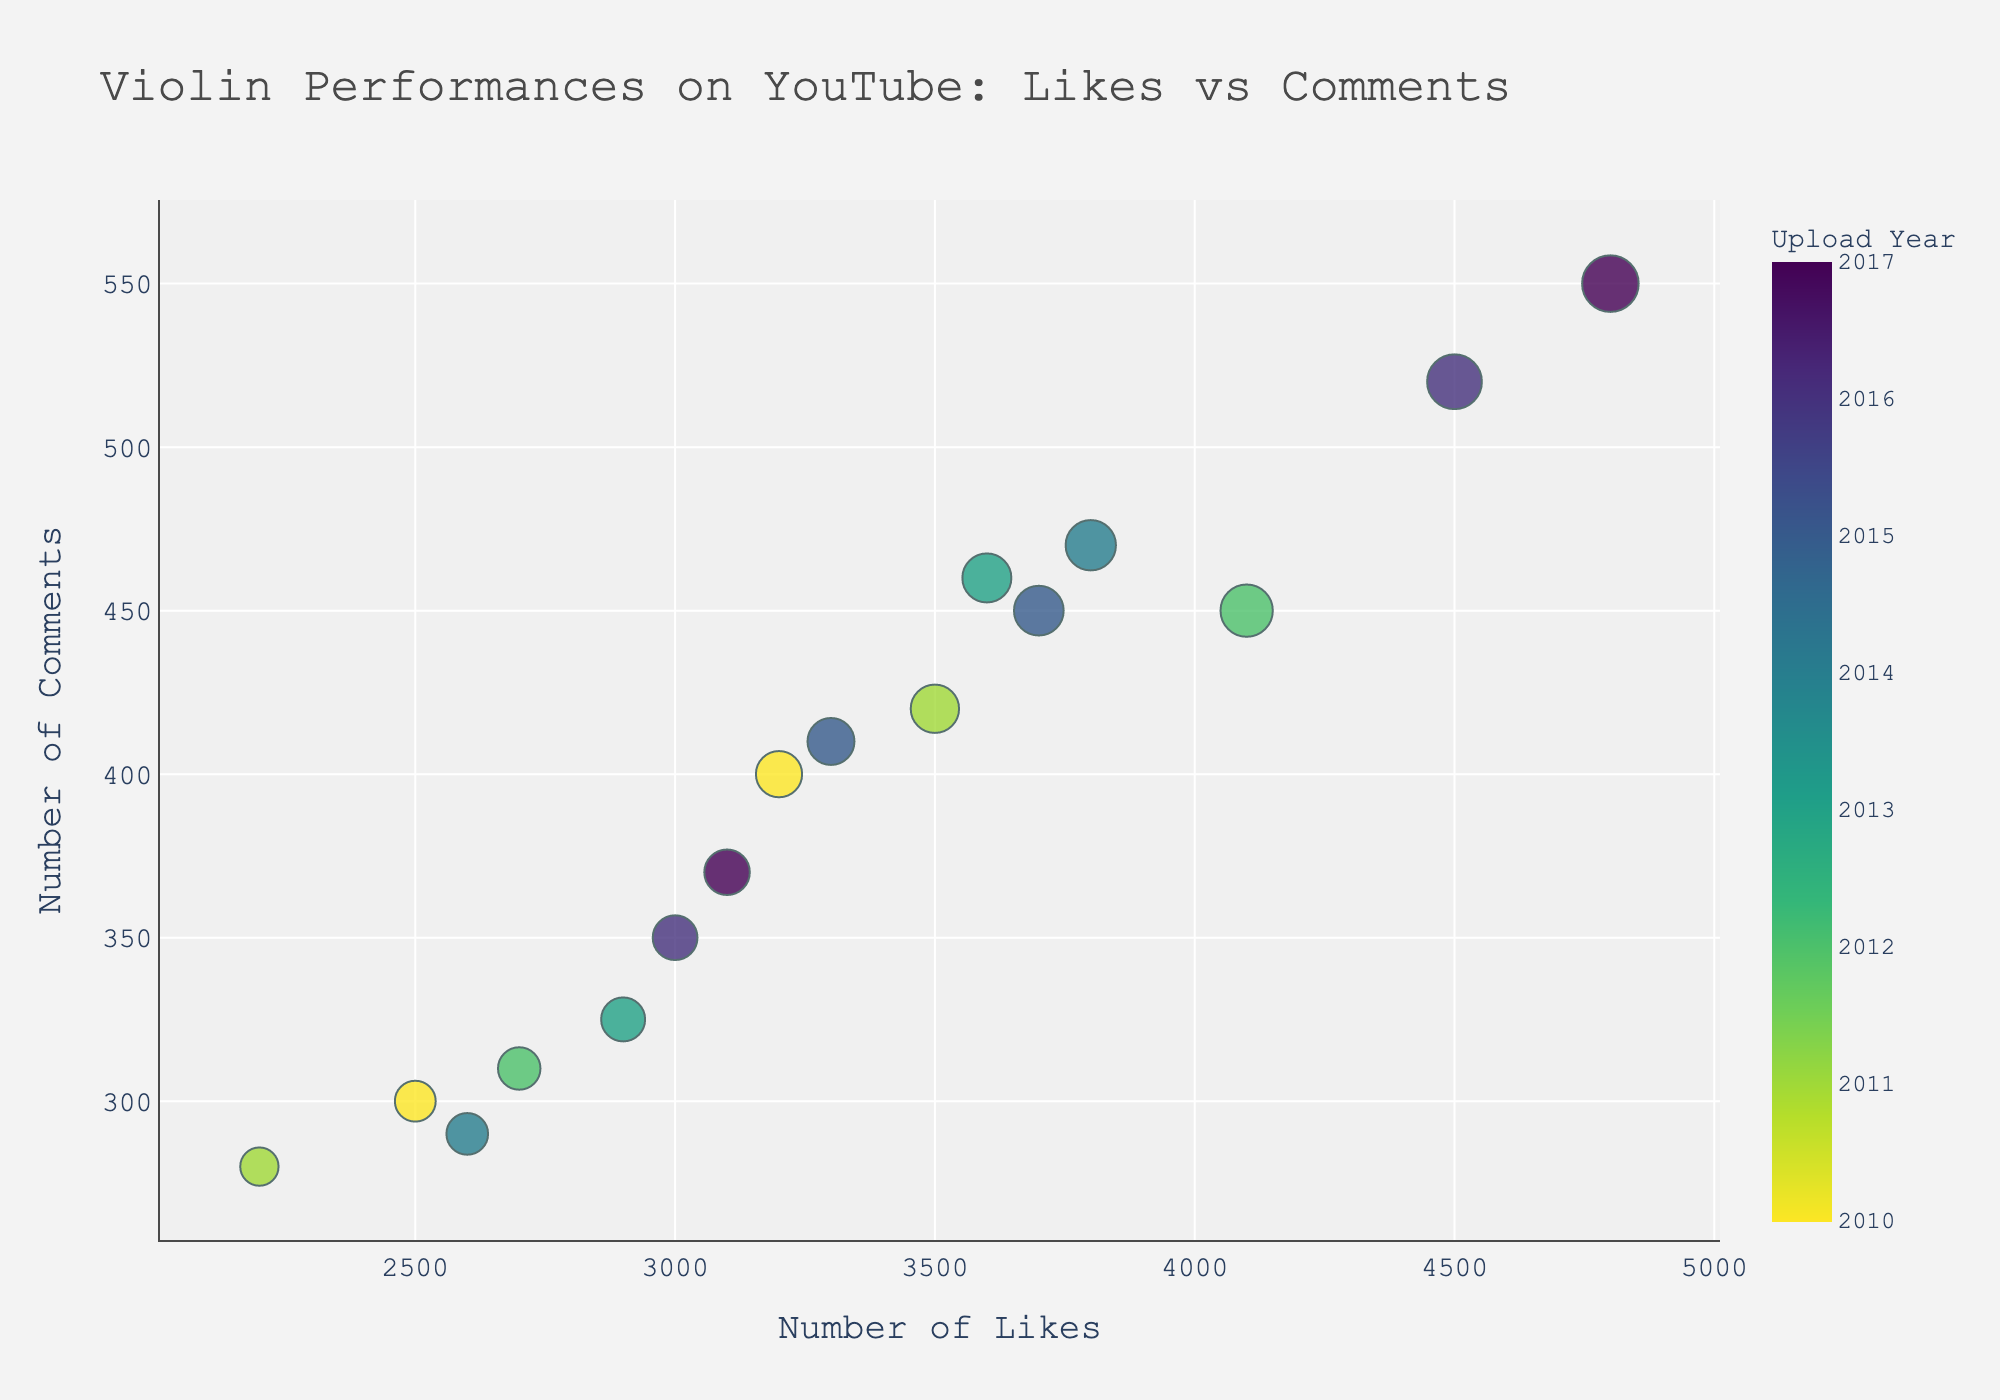How many data points are there in the plot? Count each individual data point representing a violin performance on the scatter plot.
Answer: 15 Which performance received the highest number of likes? Locate the data point with the maximum x-value (Number of Likes) on the scatter plot and identify the corresponding performance.
Answer: Csardas by Vanessa-Mae Is there any performance by Hilary Hahn? If so, how many likes did it receive? Identify any data point labeled with "Hilary Hahn" and check its x-value for the number of likes.
Answer: Yes, 3200 likes Which year has the darkest color representing its data points? Observe the color scale (Viridis in reverse) and find the darkest color that correlates with the earliest year.
Answer: 2010 What is the range of comments for performances uploaded in 2013? Identify the two data points corresponding to the year 2013 and extract their y-values (Comments) to find the range.
Answer: 325 to 460 Between anne-sophie mutter’s performances in 2011 and 2015, which one had more comments? Locate the two data points labeled "Anne-Sophie Mutter" for 2011 and 2015, then compare their y-values.
Answer: 2015 Which performance uploaded in 2016 has more likes, "Caprice No. 5" or "Beau Soir"? Identify the data points for "Caprice No. 5" and "Beau Soir" uploaded in 2016 and compare their x-values (Likes).
Answer: Caprice No. 5 What is the average number of comments on performances uploaded in 2012? Sum the comments for the data points from 2012 and divide by the number of such data points. (450 + 310) / 2 = 380
Answer: 380 How does the number of likes for "Zigeunerweisen" by Anne Akiko Meyers compare with "Meditation from Thaïs" by Sarah Chang? Find the x-values for both performances and compare them.
Answer: Zigeunerweisen has more likes Identify the year with the greatest number of performances. Count the number of data points corresponding to each upload year and identify the year with the most points.
Answer: 2017 